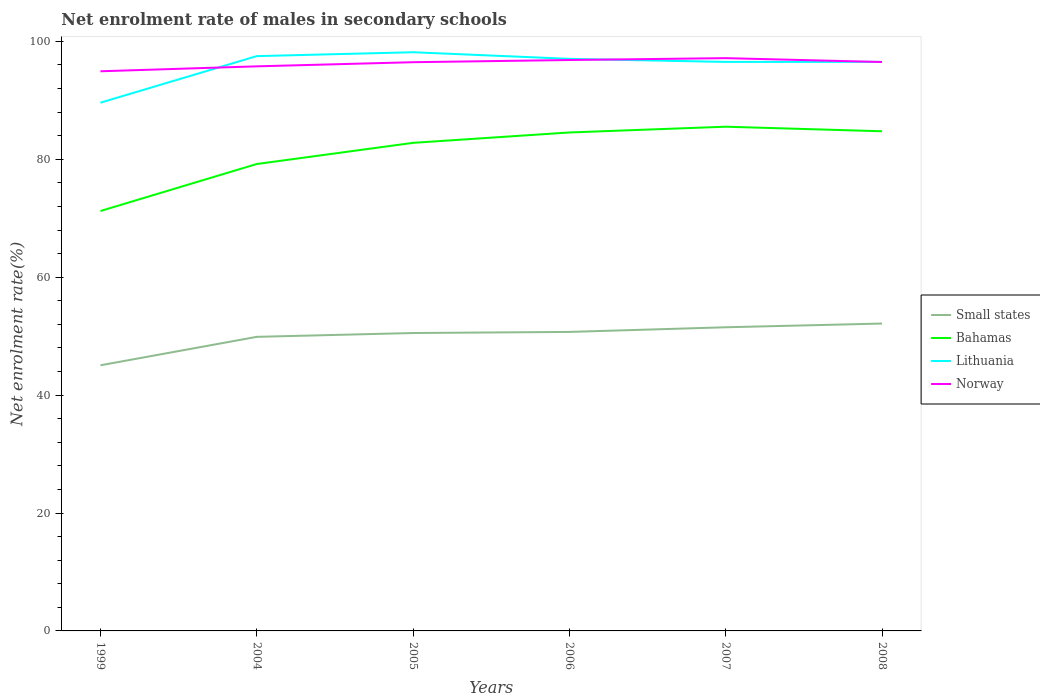How many different coloured lines are there?
Your response must be concise. 4. Is the number of lines equal to the number of legend labels?
Ensure brevity in your answer.  Yes. Across all years, what is the maximum net enrolment rate of males in secondary schools in Norway?
Your response must be concise. 94.92. What is the total net enrolment rate of males in secondary schools in Norway in the graph?
Offer a terse response. -0.03. What is the difference between the highest and the second highest net enrolment rate of males in secondary schools in Norway?
Give a very brief answer. 2.23. What is the difference between the highest and the lowest net enrolment rate of males in secondary schools in Small states?
Provide a succinct answer. 4. How many lines are there?
Make the answer very short. 4. Are the values on the major ticks of Y-axis written in scientific E-notation?
Offer a very short reply. No. Where does the legend appear in the graph?
Your answer should be compact. Center right. What is the title of the graph?
Give a very brief answer. Net enrolment rate of males in secondary schools. Does "Vanuatu" appear as one of the legend labels in the graph?
Your answer should be very brief. No. What is the label or title of the Y-axis?
Provide a short and direct response. Net enrolment rate(%). What is the Net enrolment rate(%) in Small states in 1999?
Ensure brevity in your answer.  45.06. What is the Net enrolment rate(%) in Bahamas in 1999?
Make the answer very short. 71.22. What is the Net enrolment rate(%) in Lithuania in 1999?
Offer a very short reply. 89.59. What is the Net enrolment rate(%) of Norway in 1999?
Ensure brevity in your answer.  94.92. What is the Net enrolment rate(%) in Small states in 2004?
Offer a very short reply. 49.88. What is the Net enrolment rate(%) of Bahamas in 2004?
Your answer should be very brief. 79.19. What is the Net enrolment rate(%) of Lithuania in 2004?
Offer a very short reply. 97.49. What is the Net enrolment rate(%) of Norway in 2004?
Keep it short and to the point. 95.76. What is the Net enrolment rate(%) of Small states in 2005?
Your response must be concise. 50.53. What is the Net enrolment rate(%) in Bahamas in 2005?
Your response must be concise. 82.78. What is the Net enrolment rate(%) of Lithuania in 2005?
Your answer should be compact. 98.15. What is the Net enrolment rate(%) in Norway in 2005?
Ensure brevity in your answer.  96.46. What is the Net enrolment rate(%) of Small states in 2006?
Offer a very short reply. 50.71. What is the Net enrolment rate(%) of Bahamas in 2006?
Offer a terse response. 84.54. What is the Net enrolment rate(%) of Lithuania in 2006?
Give a very brief answer. 97.03. What is the Net enrolment rate(%) of Norway in 2006?
Keep it short and to the point. 96.83. What is the Net enrolment rate(%) in Small states in 2007?
Make the answer very short. 51.5. What is the Net enrolment rate(%) of Bahamas in 2007?
Provide a succinct answer. 85.52. What is the Net enrolment rate(%) of Lithuania in 2007?
Make the answer very short. 96.51. What is the Net enrolment rate(%) of Norway in 2007?
Give a very brief answer. 97.15. What is the Net enrolment rate(%) in Small states in 2008?
Keep it short and to the point. 52.13. What is the Net enrolment rate(%) in Bahamas in 2008?
Your answer should be very brief. 84.75. What is the Net enrolment rate(%) in Lithuania in 2008?
Your answer should be compact. 96.52. What is the Net enrolment rate(%) in Norway in 2008?
Ensure brevity in your answer.  96.49. Across all years, what is the maximum Net enrolment rate(%) of Small states?
Offer a terse response. 52.13. Across all years, what is the maximum Net enrolment rate(%) in Bahamas?
Your answer should be very brief. 85.52. Across all years, what is the maximum Net enrolment rate(%) of Lithuania?
Offer a terse response. 98.15. Across all years, what is the maximum Net enrolment rate(%) in Norway?
Offer a terse response. 97.15. Across all years, what is the minimum Net enrolment rate(%) of Small states?
Ensure brevity in your answer.  45.06. Across all years, what is the minimum Net enrolment rate(%) of Bahamas?
Your answer should be very brief. 71.22. Across all years, what is the minimum Net enrolment rate(%) in Lithuania?
Your answer should be compact. 89.59. Across all years, what is the minimum Net enrolment rate(%) of Norway?
Your response must be concise. 94.92. What is the total Net enrolment rate(%) in Small states in the graph?
Ensure brevity in your answer.  299.82. What is the total Net enrolment rate(%) of Bahamas in the graph?
Make the answer very short. 488.01. What is the total Net enrolment rate(%) in Lithuania in the graph?
Your answer should be compact. 575.3. What is the total Net enrolment rate(%) of Norway in the graph?
Offer a terse response. 577.63. What is the difference between the Net enrolment rate(%) in Small states in 1999 and that in 2004?
Keep it short and to the point. -4.82. What is the difference between the Net enrolment rate(%) in Bahamas in 1999 and that in 2004?
Your answer should be very brief. -7.97. What is the difference between the Net enrolment rate(%) in Lithuania in 1999 and that in 2004?
Offer a very short reply. -7.9. What is the difference between the Net enrolment rate(%) in Norway in 1999 and that in 2004?
Provide a succinct answer. -0.84. What is the difference between the Net enrolment rate(%) in Small states in 1999 and that in 2005?
Give a very brief answer. -5.47. What is the difference between the Net enrolment rate(%) of Bahamas in 1999 and that in 2005?
Ensure brevity in your answer.  -11.56. What is the difference between the Net enrolment rate(%) of Lithuania in 1999 and that in 2005?
Your response must be concise. -8.56. What is the difference between the Net enrolment rate(%) in Norway in 1999 and that in 2005?
Your answer should be very brief. -1.54. What is the difference between the Net enrolment rate(%) in Small states in 1999 and that in 2006?
Ensure brevity in your answer.  -5.66. What is the difference between the Net enrolment rate(%) in Bahamas in 1999 and that in 2006?
Offer a very short reply. -13.32. What is the difference between the Net enrolment rate(%) in Lithuania in 1999 and that in 2006?
Offer a terse response. -7.44. What is the difference between the Net enrolment rate(%) in Norway in 1999 and that in 2006?
Offer a very short reply. -1.91. What is the difference between the Net enrolment rate(%) of Small states in 1999 and that in 2007?
Your response must be concise. -6.45. What is the difference between the Net enrolment rate(%) in Bahamas in 1999 and that in 2007?
Offer a terse response. -14.3. What is the difference between the Net enrolment rate(%) in Lithuania in 1999 and that in 2007?
Provide a succinct answer. -6.92. What is the difference between the Net enrolment rate(%) of Norway in 1999 and that in 2007?
Provide a succinct answer. -2.23. What is the difference between the Net enrolment rate(%) in Small states in 1999 and that in 2008?
Your answer should be compact. -7.08. What is the difference between the Net enrolment rate(%) in Bahamas in 1999 and that in 2008?
Offer a very short reply. -13.53. What is the difference between the Net enrolment rate(%) in Lithuania in 1999 and that in 2008?
Provide a succinct answer. -6.93. What is the difference between the Net enrolment rate(%) of Norway in 1999 and that in 2008?
Your response must be concise. -1.57. What is the difference between the Net enrolment rate(%) of Small states in 2004 and that in 2005?
Ensure brevity in your answer.  -0.65. What is the difference between the Net enrolment rate(%) in Bahamas in 2004 and that in 2005?
Give a very brief answer. -3.59. What is the difference between the Net enrolment rate(%) in Lithuania in 2004 and that in 2005?
Your response must be concise. -0.66. What is the difference between the Net enrolment rate(%) of Norway in 2004 and that in 2005?
Make the answer very short. -0.7. What is the difference between the Net enrolment rate(%) of Small states in 2004 and that in 2006?
Provide a succinct answer. -0.83. What is the difference between the Net enrolment rate(%) of Bahamas in 2004 and that in 2006?
Provide a short and direct response. -5.35. What is the difference between the Net enrolment rate(%) in Lithuania in 2004 and that in 2006?
Provide a succinct answer. 0.46. What is the difference between the Net enrolment rate(%) of Norway in 2004 and that in 2006?
Provide a short and direct response. -1.07. What is the difference between the Net enrolment rate(%) in Small states in 2004 and that in 2007?
Provide a short and direct response. -1.62. What is the difference between the Net enrolment rate(%) in Bahamas in 2004 and that in 2007?
Ensure brevity in your answer.  -6.33. What is the difference between the Net enrolment rate(%) in Lithuania in 2004 and that in 2007?
Provide a succinct answer. 0.98. What is the difference between the Net enrolment rate(%) of Norway in 2004 and that in 2007?
Provide a succinct answer. -1.39. What is the difference between the Net enrolment rate(%) in Small states in 2004 and that in 2008?
Make the answer very short. -2.25. What is the difference between the Net enrolment rate(%) of Bahamas in 2004 and that in 2008?
Make the answer very short. -5.55. What is the difference between the Net enrolment rate(%) in Lithuania in 2004 and that in 2008?
Your answer should be very brief. 0.97. What is the difference between the Net enrolment rate(%) in Norway in 2004 and that in 2008?
Give a very brief answer. -0.73. What is the difference between the Net enrolment rate(%) in Small states in 2005 and that in 2006?
Ensure brevity in your answer.  -0.19. What is the difference between the Net enrolment rate(%) of Bahamas in 2005 and that in 2006?
Your answer should be very brief. -1.76. What is the difference between the Net enrolment rate(%) of Lithuania in 2005 and that in 2006?
Make the answer very short. 1.12. What is the difference between the Net enrolment rate(%) of Norway in 2005 and that in 2006?
Make the answer very short. -0.37. What is the difference between the Net enrolment rate(%) in Small states in 2005 and that in 2007?
Provide a succinct answer. -0.98. What is the difference between the Net enrolment rate(%) of Bahamas in 2005 and that in 2007?
Provide a short and direct response. -2.74. What is the difference between the Net enrolment rate(%) in Lithuania in 2005 and that in 2007?
Your answer should be compact. 1.65. What is the difference between the Net enrolment rate(%) of Norway in 2005 and that in 2007?
Provide a short and direct response. -0.69. What is the difference between the Net enrolment rate(%) in Small states in 2005 and that in 2008?
Your answer should be very brief. -1.61. What is the difference between the Net enrolment rate(%) of Bahamas in 2005 and that in 2008?
Ensure brevity in your answer.  -1.96. What is the difference between the Net enrolment rate(%) of Lithuania in 2005 and that in 2008?
Offer a very short reply. 1.63. What is the difference between the Net enrolment rate(%) in Norway in 2005 and that in 2008?
Keep it short and to the point. -0.03. What is the difference between the Net enrolment rate(%) in Small states in 2006 and that in 2007?
Provide a short and direct response. -0.79. What is the difference between the Net enrolment rate(%) of Bahamas in 2006 and that in 2007?
Your answer should be compact. -0.98. What is the difference between the Net enrolment rate(%) of Lithuania in 2006 and that in 2007?
Your answer should be very brief. 0.52. What is the difference between the Net enrolment rate(%) of Norway in 2006 and that in 2007?
Your answer should be compact. -0.32. What is the difference between the Net enrolment rate(%) of Small states in 2006 and that in 2008?
Your answer should be very brief. -1.42. What is the difference between the Net enrolment rate(%) in Bahamas in 2006 and that in 2008?
Offer a very short reply. -0.2. What is the difference between the Net enrolment rate(%) of Lithuania in 2006 and that in 2008?
Your response must be concise. 0.51. What is the difference between the Net enrolment rate(%) in Norway in 2006 and that in 2008?
Your answer should be very brief. 0.34. What is the difference between the Net enrolment rate(%) of Small states in 2007 and that in 2008?
Provide a succinct answer. -0.63. What is the difference between the Net enrolment rate(%) in Bahamas in 2007 and that in 2008?
Your answer should be compact. 0.77. What is the difference between the Net enrolment rate(%) of Lithuania in 2007 and that in 2008?
Your answer should be very brief. -0.01. What is the difference between the Net enrolment rate(%) in Norway in 2007 and that in 2008?
Ensure brevity in your answer.  0.66. What is the difference between the Net enrolment rate(%) of Small states in 1999 and the Net enrolment rate(%) of Bahamas in 2004?
Your response must be concise. -34.14. What is the difference between the Net enrolment rate(%) in Small states in 1999 and the Net enrolment rate(%) in Lithuania in 2004?
Offer a terse response. -52.44. What is the difference between the Net enrolment rate(%) in Small states in 1999 and the Net enrolment rate(%) in Norway in 2004?
Your answer should be compact. -50.7. What is the difference between the Net enrolment rate(%) in Bahamas in 1999 and the Net enrolment rate(%) in Lithuania in 2004?
Offer a terse response. -26.27. What is the difference between the Net enrolment rate(%) in Bahamas in 1999 and the Net enrolment rate(%) in Norway in 2004?
Your response must be concise. -24.54. What is the difference between the Net enrolment rate(%) of Lithuania in 1999 and the Net enrolment rate(%) of Norway in 2004?
Provide a succinct answer. -6.17. What is the difference between the Net enrolment rate(%) of Small states in 1999 and the Net enrolment rate(%) of Bahamas in 2005?
Your response must be concise. -37.73. What is the difference between the Net enrolment rate(%) of Small states in 1999 and the Net enrolment rate(%) of Lithuania in 2005?
Keep it short and to the point. -53.1. What is the difference between the Net enrolment rate(%) of Small states in 1999 and the Net enrolment rate(%) of Norway in 2005?
Provide a short and direct response. -51.41. What is the difference between the Net enrolment rate(%) of Bahamas in 1999 and the Net enrolment rate(%) of Lithuania in 2005?
Make the answer very short. -26.94. What is the difference between the Net enrolment rate(%) of Bahamas in 1999 and the Net enrolment rate(%) of Norway in 2005?
Your answer should be compact. -25.24. What is the difference between the Net enrolment rate(%) in Lithuania in 1999 and the Net enrolment rate(%) in Norway in 2005?
Provide a short and direct response. -6.87. What is the difference between the Net enrolment rate(%) in Small states in 1999 and the Net enrolment rate(%) in Bahamas in 2006?
Provide a succinct answer. -39.49. What is the difference between the Net enrolment rate(%) of Small states in 1999 and the Net enrolment rate(%) of Lithuania in 2006?
Give a very brief answer. -51.98. What is the difference between the Net enrolment rate(%) in Small states in 1999 and the Net enrolment rate(%) in Norway in 2006?
Make the answer very short. -51.78. What is the difference between the Net enrolment rate(%) of Bahamas in 1999 and the Net enrolment rate(%) of Lithuania in 2006?
Give a very brief answer. -25.81. What is the difference between the Net enrolment rate(%) of Bahamas in 1999 and the Net enrolment rate(%) of Norway in 2006?
Keep it short and to the point. -25.61. What is the difference between the Net enrolment rate(%) of Lithuania in 1999 and the Net enrolment rate(%) of Norway in 2006?
Ensure brevity in your answer.  -7.24. What is the difference between the Net enrolment rate(%) of Small states in 1999 and the Net enrolment rate(%) of Bahamas in 2007?
Ensure brevity in your answer.  -40.47. What is the difference between the Net enrolment rate(%) in Small states in 1999 and the Net enrolment rate(%) in Lithuania in 2007?
Your response must be concise. -51.45. What is the difference between the Net enrolment rate(%) in Small states in 1999 and the Net enrolment rate(%) in Norway in 2007?
Make the answer very short. -52.09. What is the difference between the Net enrolment rate(%) of Bahamas in 1999 and the Net enrolment rate(%) of Lithuania in 2007?
Your answer should be compact. -25.29. What is the difference between the Net enrolment rate(%) in Bahamas in 1999 and the Net enrolment rate(%) in Norway in 2007?
Make the answer very short. -25.93. What is the difference between the Net enrolment rate(%) of Lithuania in 1999 and the Net enrolment rate(%) of Norway in 2007?
Your answer should be compact. -7.56. What is the difference between the Net enrolment rate(%) in Small states in 1999 and the Net enrolment rate(%) in Bahamas in 2008?
Ensure brevity in your answer.  -39.69. What is the difference between the Net enrolment rate(%) in Small states in 1999 and the Net enrolment rate(%) in Lithuania in 2008?
Provide a succinct answer. -51.46. What is the difference between the Net enrolment rate(%) in Small states in 1999 and the Net enrolment rate(%) in Norway in 2008?
Your answer should be very brief. -51.44. What is the difference between the Net enrolment rate(%) in Bahamas in 1999 and the Net enrolment rate(%) in Lithuania in 2008?
Offer a very short reply. -25.3. What is the difference between the Net enrolment rate(%) in Bahamas in 1999 and the Net enrolment rate(%) in Norway in 2008?
Your answer should be very brief. -25.28. What is the difference between the Net enrolment rate(%) of Lithuania in 1999 and the Net enrolment rate(%) of Norway in 2008?
Keep it short and to the point. -6.9. What is the difference between the Net enrolment rate(%) of Small states in 2004 and the Net enrolment rate(%) of Bahamas in 2005?
Your answer should be compact. -32.9. What is the difference between the Net enrolment rate(%) in Small states in 2004 and the Net enrolment rate(%) in Lithuania in 2005?
Ensure brevity in your answer.  -48.27. What is the difference between the Net enrolment rate(%) in Small states in 2004 and the Net enrolment rate(%) in Norway in 2005?
Your answer should be compact. -46.58. What is the difference between the Net enrolment rate(%) in Bahamas in 2004 and the Net enrolment rate(%) in Lithuania in 2005?
Your response must be concise. -18.96. What is the difference between the Net enrolment rate(%) in Bahamas in 2004 and the Net enrolment rate(%) in Norway in 2005?
Make the answer very short. -17.27. What is the difference between the Net enrolment rate(%) of Lithuania in 2004 and the Net enrolment rate(%) of Norway in 2005?
Provide a succinct answer. 1.03. What is the difference between the Net enrolment rate(%) of Small states in 2004 and the Net enrolment rate(%) of Bahamas in 2006?
Provide a succinct answer. -34.66. What is the difference between the Net enrolment rate(%) in Small states in 2004 and the Net enrolment rate(%) in Lithuania in 2006?
Give a very brief answer. -47.15. What is the difference between the Net enrolment rate(%) in Small states in 2004 and the Net enrolment rate(%) in Norway in 2006?
Your answer should be compact. -46.95. What is the difference between the Net enrolment rate(%) in Bahamas in 2004 and the Net enrolment rate(%) in Lithuania in 2006?
Ensure brevity in your answer.  -17.84. What is the difference between the Net enrolment rate(%) of Bahamas in 2004 and the Net enrolment rate(%) of Norway in 2006?
Provide a short and direct response. -17.64. What is the difference between the Net enrolment rate(%) in Lithuania in 2004 and the Net enrolment rate(%) in Norway in 2006?
Provide a short and direct response. 0.66. What is the difference between the Net enrolment rate(%) in Small states in 2004 and the Net enrolment rate(%) in Bahamas in 2007?
Keep it short and to the point. -35.64. What is the difference between the Net enrolment rate(%) of Small states in 2004 and the Net enrolment rate(%) of Lithuania in 2007?
Your response must be concise. -46.63. What is the difference between the Net enrolment rate(%) of Small states in 2004 and the Net enrolment rate(%) of Norway in 2007?
Your answer should be very brief. -47.27. What is the difference between the Net enrolment rate(%) of Bahamas in 2004 and the Net enrolment rate(%) of Lithuania in 2007?
Keep it short and to the point. -17.32. What is the difference between the Net enrolment rate(%) in Bahamas in 2004 and the Net enrolment rate(%) in Norway in 2007?
Your answer should be very brief. -17.96. What is the difference between the Net enrolment rate(%) in Lithuania in 2004 and the Net enrolment rate(%) in Norway in 2007?
Make the answer very short. 0.34. What is the difference between the Net enrolment rate(%) of Small states in 2004 and the Net enrolment rate(%) of Bahamas in 2008?
Provide a succinct answer. -34.87. What is the difference between the Net enrolment rate(%) of Small states in 2004 and the Net enrolment rate(%) of Lithuania in 2008?
Your response must be concise. -46.64. What is the difference between the Net enrolment rate(%) of Small states in 2004 and the Net enrolment rate(%) of Norway in 2008?
Offer a terse response. -46.61. What is the difference between the Net enrolment rate(%) in Bahamas in 2004 and the Net enrolment rate(%) in Lithuania in 2008?
Provide a succinct answer. -17.33. What is the difference between the Net enrolment rate(%) of Bahamas in 2004 and the Net enrolment rate(%) of Norway in 2008?
Keep it short and to the point. -17.3. What is the difference between the Net enrolment rate(%) in Lithuania in 2004 and the Net enrolment rate(%) in Norway in 2008?
Make the answer very short. 1. What is the difference between the Net enrolment rate(%) of Small states in 2005 and the Net enrolment rate(%) of Bahamas in 2006?
Your answer should be compact. -34.02. What is the difference between the Net enrolment rate(%) of Small states in 2005 and the Net enrolment rate(%) of Lithuania in 2006?
Your answer should be compact. -46.5. What is the difference between the Net enrolment rate(%) of Small states in 2005 and the Net enrolment rate(%) of Norway in 2006?
Keep it short and to the point. -46.31. What is the difference between the Net enrolment rate(%) in Bahamas in 2005 and the Net enrolment rate(%) in Lithuania in 2006?
Keep it short and to the point. -14.25. What is the difference between the Net enrolment rate(%) of Bahamas in 2005 and the Net enrolment rate(%) of Norway in 2006?
Offer a very short reply. -14.05. What is the difference between the Net enrolment rate(%) in Lithuania in 2005 and the Net enrolment rate(%) in Norway in 2006?
Your response must be concise. 1.32. What is the difference between the Net enrolment rate(%) in Small states in 2005 and the Net enrolment rate(%) in Bahamas in 2007?
Ensure brevity in your answer.  -34.99. What is the difference between the Net enrolment rate(%) of Small states in 2005 and the Net enrolment rate(%) of Lithuania in 2007?
Your answer should be very brief. -45.98. What is the difference between the Net enrolment rate(%) in Small states in 2005 and the Net enrolment rate(%) in Norway in 2007?
Give a very brief answer. -46.62. What is the difference between the Net enrolment rate(%) of Bahamas in 2005 and the Net enrolment rate(%) of Lithuania in 2007?
Give a very brief answer. -13.73. What is the difference between the Net enrolment rate(%) in Bahamas in 2005 and the Net enrolment rate(%) in Norway in 2007?
Keep it short and to the point. -14.37. What is the difference between the Net enrolment rate(%) in Lithuania in 2005 and the Net enrolment rate(%) in Norway in 2007?
Make the answer very short. 1. What is the difference between the Net enrolment rate(%) in Small states in 2005 and the Net enrolment rate(%) in Bahamas in 2008?
Give a very brief answer. -34.22. What is the difference between the Net enrolment rate(%) in Small states in 2005 and the Net enrolment rate(%) in Lithuania in 2008?
Provide a succinct answer. -45.99. What is the difference between the Net enrolment rate(%) in Small states in 2005 and the Net enrolment rate(%) in Norway in 2008?
Keep it short and to the point. -45.97. What is the difference between the Net enrolment rate(%) of Bahamas in 2005 and the Net enrolment rate(%) of Lithuania in 2008?
Provide a succinct answer. -13.74. What is the difference between the Net enrolment rate(%) in Bahamas in 2005 and the Net enrolment rate(%) in Norway in 2008?
Your answer should be very brief. -13.71. What is the difference between the Net enrolment rate(%) of Lithuania in 2005 and the Net enrolment rate(%) of Norway in 2008?
Give a very brief answer. 1.66. What is the difference between the Net enrolment rate(%) in Small states in 2006 and the Net enrolment rate(%) in Bahamas in 2007?
Make the answer very short. -34.81. What is the difference between the Net enrolment rate(%) of Small states in 2006 and the Net enrolment rate(%) of Lithuania in 2007?
Offer a terse response. -45.79. What is the difference between the Net enrolment rate(%) in Small states in 2006 and the Net enrolment rate(%) in Norway in 2007?
Keep it short and to the point. -46.44. What is the difference between the Net enrolment rate(%) in Bahamas in 2006 and the Net enrolment rate(%) in Lithuania in 2007?
Offer a very short reply. -11.97. What is the difference between the Net enrolment rate(%) of Bahamas in 2006 and the Net enrolment rate(%) of Norway in 2007?
Your response must be concise. -12.61. What is the difference between the Net enrolment rate(%) of Lithuania in 2006 and the Net enrolment rate(%) of Norway in 2007?
Your answer should be compact. -0.12. What is the difference between the Net enrolment rate(%) of Small states in 2006 and the Net enrolment rate(%) of Bahamas in 2008?
Your answer should be compact. -34.03. What is the difference between the Net enrolment rate(%) in Small states in 2006 and the Net enrolment rate(%) in Lithuania in 2008?
Ensure brevity in your answer.  -45.81. What is the difference between the Net enrolment rate(%) of Small states in 2006 and the Net enrolment rate(%) of Norway in 2008?
Your response must be concise. -45.78. What is the difference between the Net enrolment rate(%) of Bahamas in 2006 and the Net enrolment rate(%) of Lithuania in 2008?
Offer a terse response. -11.98. What is the difference between the Net enrolment rate(%) of Bahamas in 2006 and the Net enrolment rate(%) of Norway in 2008?
Offer a terse response. -11.95. What is the difference between the Net enrolment rate(%) in Lithuania in 2006 and the Net enrolment rate(%) in Norway in 2008?
Give a very brief answer. 0.54. What is the difference between the Net enrolment rate(%) in Small states in 2007 and the Net enrolment rate(%) in Bahamas in 2008?
Your answer should be very brief. -33.24. What is the difference between the Net enrolment rate(%) in Small states in 2007 and the Net enrolment rate(%) in Lithuania in 2008?
Keep it short and to the point. -45.02. What is the difference between the Net enrolment rate(%) in Small states in 2007 and the Net enrolment rate(%) in Norway in 2008?
Your response must be concise. -44.99. What is the difference between the Net enrolment rate(%) of Bahamas in 2007 and the Net enrolment rate(%) of Lithuania in 2008?
Keep it short and to the point. -11. What is the difference between the Net enrolment rate(%) of Bahamas in 2007 and the Net enrolment rate(%) of Norway in 2008?
Offer a very short reply. -10.97. What is the difference between the Net enrolment rate(%) in Lithuania in 2007 and the Net enrolment rate(%) in Norway in 2008?
Make the answer very short. 0.01. What is the average Net enrolment rate(%) in Small states per year?
Provide a succinct answer. 49.97. What is the average Net enrolment rate(%) of Bahamas per year?
Ensure brevity in your answer.  81.33. What is the average Net enrolment rate(%) of Lithuania per year?
Provide a succinct answer. 95.88. What is the average Net enrolment rate(%) of Norway per year?
Offer a terse response. 96.27. In the year 1999, what is the difference between the Net enrolment rate(%) in Small states and Net enrolment rate(%) in Bahamas?
Offer a terse response. -26.16. In the year 1999, what is the difference between the Net enrolment rate(%) in Small states and Net enrolment rate(%) in Lithuania?
Offer a terse response. -44.54. In the year 1999, what is the difference between the Net enrolment rate(%) in Small states and Net enrolment rate(%) in Norway?
Provide a short and direct response. -49.87. In the year 1999, what is the difference between the Net enrolment rate(%) in Bahamas and Net enrolment rate(%) in Lithuania?
Your response must be concise. -18.38. In the year 1999, what is the difference between the Net enrolment rate(%) in Bahamas and Net enrolment rate(%) in Norway?
Make the answer very short. -23.7. In the year 1999, what is the difference between the Net enrolment rate(%) in Lithuania and Net enrolment rate(%) in Norway?
Offer a very short reply. -5.33. In the year 2004, what is the difference between the Net enrolment rate(%) in Small states and Net enrolment rate(%) in Bahamas?
Give a very brief answer. -29.31. In the year 2004, what is the difference between the Net enrolment rate(%) of Small states and Net enrolment rate(%) of Lithuania?
Provide a succinct answer. -47.61. In the year 2004, what is the difference between the Net enrolment rate(%) in Small states and Net enrolment rate(%) in Norway?
Provide a succinct answer. -45.88. In the year 2004, what is the difference between the Net enrolment rate(%) in Bahamas and Net enrolment rate(%) in Lithuania?
Offer a very short reply. -18.3. In the year 2004, what is the difference between the Net enrolment rate(%) in Bahamas and Net enrolment rate(%) in Norway?
Provide a short and direct response. -16.57. In the year 2004, what is the difference between the Net enrolment rate(%) in Lithuania and Net enrolment rate(%) in Norway?
Make the answer very short. 1.73. In the year 2005, what is the difference between the Net enrolment rate(%) in Small states and Net enrolment rate(%) in Bahamas?
Offer a very short reply. -32.26. In the year 2005, what is the difference between the Net enrolment rate(%) of Small states and Net enrolment rate(%) of Lithuania?
Your answer should be compact. -47.63. In the year 2005, what is the difference between the Net enrolment rate(%) in Small states and Net enrolment rate(%) in Norway?
Keep it short and to the point. -45.94. In the year 2005, what is the difference between the Net enrolment rate(%) in Bahamas and Net enrolment rate(%) in Lithuania?
Ensure brevity in your answer.  -15.37. In the year 2005, what is the difference between the Net enrolment rate(%) of Bahamas and Net enrolment rate(%) of Norway?
Make the answer very short. -13.68. In the year 2005, what is the difference between the Net enrolment rate(%) of Lithuania and Net enrolment rate(%) of Norway?
Give a very brief answer. 1.69. In the year 2006, what is the difference between the Net enrolment rate(%) of Small states and Net enrolment rate(%) of Bahamas?
Your response must be concise. -33.83. In the year 2006, what is the difference between the Net enrolment rate(%) in Small states and Net enrolment rate(%) in Lithuania?
Provide a short and direct response. -46.32. In the year 2006, what is the difference between the Net enrolment rate(%) of Small states and Net enrolment rate(%) of Norway?
Provide a short and direct response. -46.12. In the year 2006, what is the difference between the Net enrolment rate(%) of Bahamas and Net enrolment rate(%) of Lithuania?
Provide a short and direct response. -12.49. In the year 2006, what is the difference between the Net enrolment rate(%) in Bahamas and Net enrolment rate(%) in Norway?
Provide a short and direct response. -12.29. In the year 2006, what is the difference between the Net enrolment rate(%) of Lithuania and Net enrolment rate(%) of Norway?
Your answer should be compact. 0.2. In the year 2007, what is the difference between the Net enrolment rate(%) in Small states and Net enrolment rate(%) in Bahamas?
Offer a very short reply. -34.02. In the year 2007, what is the difference between the Net enrolment rate(%) in Small states and Net enrolment rate(%) in Lithuania?
Offer a very short reply. -45.01. In the year 2007, what is the difference between the Net enrolment rate(%) of Small states and Net enrolment rate(%) of Norway?
Ensure brevity in your answer.  -45.65. In the year 2007, what is the difference between the Net enrolment rate(%) in Bahamas and Net enrolment rate(%) in Lithuania?
Keep it short and to the point. -10.99. In the year 2007, what is the difference between the Net enrolment rate(%) in Bahamas and Net enrolment rate(%) in Norway?
Your answer should be very brief. -11.63. In the year 2007, what is the difference between the Net enrolment rate(%) in Lithuania and Net enrolment rate(%) in Norway?
Offer a very short reply. -0.64. In the year 2008, what is the difference between the Net enrolment rate(%) of Small states and Net enrolment rate(%) of Bahamas?
Your answer should be compact. -32.61. In the year 2008, what is the difference between the Net enrolment rate(%) in Small states and Net enrolment rate(%) in Lithuania?
Your answer should be compact. -44.39. In the year 2008, what is the difference between the Net enrolment rate(%) of Small states and Net enrolment rate(%) of Norway?
Ensure brevity in your answer.  -44.36. In the year 2008, what is the difference between the Net enrolment rate(%) in Bahamas and Net enrolment rate(%) in Lithuania?
Offer a very short reply. -11.77. In the year 2008, what is the difference between the Net enrolment rate(%) of Bahamas and Net enrolment rate(%) of Norway?
Your answer should be very brief. -11.75. In the year 2008, what is the difference between the Net enrolment rate(%) in Lithuania and Net enrolment rate(%) in Norway?
Provide a short and direct response. 0.03. What is the ratio of the Net enrolment rate(%) in Small states in 1999 to that in 2004?
Your answer should be very brief. 0.9. What is the ratio of the Net enrolment rate(%) of Bahamas in 1999 to that in 2004?
Provide a succinct answer. 0.9. What is the ratio of the Net enrolment rate(%) in Lithuania in 1999 to that in 2004?
Provide a short and direct response. 0.92. What is the ratio of the Net enrolment rate(%) in Norway in 1999 to that in 2004?
Offer a terse response. 0.99. What is the ratio of the Net enrolment rate(%) in Small states in 1999 to that in 2005?
Offer a terse response. 0.89. What is the ratio of the Net enrolment rate(%) in Bahamas in 1999 to that in 2005?
Offer a very short reply. 0.86. What is the ratio of the Net enrolment rate(%) in Lithuania in 1999 to that in 2005?
Keep it short and to the point. 0.91. What is the ratio of the Net enrolment rate(%) of Small states in 1999 to that in 2006?
Provide a short and direct response. 0.89. What is the ratio of the Net enrolment rate(%) in Bahamas in 1999 to that in 2006?
Your response must be concise. 0.84. What is the ratio of the Net enrolment rate(%) in Lithuania in 1999 to that in 2006?
Provide a succinct answer. 0.92. What is the ratio of the Net enrolment rate(%) in Norway in 1999 to that in 2006?
Give a very brief answer. 0.98. What is the ratio of the Net enrolment rate(%) in Small states in 1999 to that in 2007?
Offer a very short reply. 0.87. What is the ratio of the Net enrolment rate(%) of Bahamas in 1999 to that in 2007?
Ensure brevity in your answer.  0.83. What is the ratio of the Net enrolment rate(%) of Lithuania in 1999 to that in 2007?
Your answer should be very brief. 0.93. What is the ratio of the Net enrolment rate(%) in Norway in 1999 to that in 2007?
Your response must be concise. 0.98. What is the ratio of the Net enrolment rate(%) of Small states in 1999 to that in 2008?
Keep it short and to the point. 0.86. What is the ratio of the Net enrolment rate(%) in Bahamas in 1999 to that in 2008?
Provide a short and direct response. 0.84. What is the ratio of the Net enrolment rate(%) in Lithuania in 1999 to that in 2008?
Offer a very short reply. 0.93. What is the ratio of the Net enrolment rate(%) in Norway in 1999 to that in 2008?
Your answer should be compact. 0.98. What is the ratio of the Net enrolment rate(%) of Small states in 2004 to that in 2005?
Offer a very short reply. 0.99. What is the ratio of the Net enrolment rate(%) of Bahamas in 2004 to that in 2005?
Make the answer very short. 0.96. What is the ratio of the Net enrolment rate(%) of Lithuania in 2004 to that in 2005?
Offer a very short reply. 0.99. What is the ratio of the Net enrolment rate(%) of Norway in 2004 to that in 2005?
Give a very brief answer. 0.99. What is the ratio of the Net enrolment rate(%) in Small states in 2004 to that in 2006?
Your answer should be very brief. 0.98. What is the ratio of the Net enrolment rate(%) in Bahamas in 2004 to that in 2006?
Provide a short and direct response. 0.94. What is the ratio of the Net enrolment rate(%) of Norway in 2004 to that in 2006?
Your answer should be compact. 0.99. What is the ratio of the Net enrolment rate(%) of Small states in 2004 to that in 2007?
Provide a succinct answer. 0.97. What is the ratio of the Net enrolment rate(%) of Bahamas in 2004 to that in 2007?
Make the answer very short. 0.93. What is the ratio of the Net enrolment rate(%) of Lithuania in 2004 to that in 2007?
Your response must be concise. 1.01. What is the ratio of the Net enrolment rate(%) in Norway in 2004 to that in 2007?
Your answer should be very brief. 0.99. What is the ratio of the Net enrolment rate(%) of Small states in 2004 to that in 2008?
Provide a short and direct response. 0.96. What is the ratio of the Net enrolment rate(%) of Bahamas in 2004 to that in 2008?
Your answer should be very brief. 0.93. What is the ratio of the Net enrolment rate(%) of Lithuania in 2004 to that in 2008?
Ensure brevity in your answer.  1.01. What is the ratio of the Net enrolment rate(%) of Bahamas in 2005 to that in 2006?
Your answer should be very brief. 0.98. What is the ratio of the Net enrolment rate(%) in Lithuania in 2005 to that in 2006?
Give a very brief answer. 1.01. What is the ratio of the Net enrolment rate(%) of Norway in 2005 to that in 2006?
Offer a terse response. 1. What is the ratio of the Net enrolment rate(%) of Bahamas in 2005 to that in 2007?
Offer a terse response. 0.97. What is the ratio of the Net enrolment rate(%) of Small states in 2005 to that in 2008?
Your answer should be compact. 0.97. What is the ratio of the Net enrolment rate(%) of Bahamas in 2005 to that in 2008?
Ensure brevity in your answer.  0.98. What is the ratio of the Net enrolment rate(%) of Lithuania in 2005 to that in 2008?
Give a very brief answer. 1.02. What is the ratio of the Net enrolment rate(%) of Norway in 2005 to that in 2008?
Your response must be concise. 1. What is the ratio of the Net enrolment rate(%) of Small states in 2006 to that in 2007?
Provide a succinct answer. 0.98. What is the ratio of the Net enrolment rate(%) in Bahamas in 2006 to that in 2007?
Your answer should be very brief. 0.99. What is the ratio of the Net enrolment rate(%) in Lithuania in 2006 to that in 2007?
Your answer should be very brief. 1.01. What is the ratio of the Net enrolment rate(%) in Norway in 2006 to that in 2007?
Ensure brevity in your answer.  1. What is the ratio of the Net enrolment rate(%) of Small states in 2006 to that in 2008?
Keep it short and to the point. 0.97. What is the ratio of the Net enrolment rate(%) of Norway in 2006 to that in 2008?
Your answer should be compact. 1. What is the ratio of the Net enrolment rate(%) in Small states in 2007 to that in 2008?
Provide a succinct answer. 0.99. What is the ratio of the Net enrolment rate(%) of Bahamas in 2007 to that in 2008?
Ensure brevity in your answer.  1.01. What is the ratio of the Net enrolment rate(%) of Norway in 2007 to that in 2008?
Provide a succinct answer. 1.01. What is the difference between the highest and the second highest Net enrolment rate(%) of Small states?
Provide a succinct answer. 0.63. What is the difference between the highest and the second highest Net enrolment rate(%) in Bahamas?
Ensure brevity in your answer.  0.77. What is the difference between the highest and the second highest Net enrolment rate(%) of Lithuania?
Give a very brief answer. 0.66. What is the difference between the highest and the second highest Net enrolment rate(%) in Norway?
Give a very brief answer. 0.32. What is the difference between the highest and the lowest Net enrolment rate(%) of Small states?
Give a very brief answer. 7.08. What is the difference between the highest and the lowest Net enrolment rate(%) in Bahamas?
Provide a succinct answer. 14.3. What is the difference between the highest and the lowest Net enrolment rate(%) in Lithuania?
Offer a terse response. 8.56. What is the difference between the highest and the lowest Net enrolment rate(%) in Norway?
Offer a terse response. 2.23. 